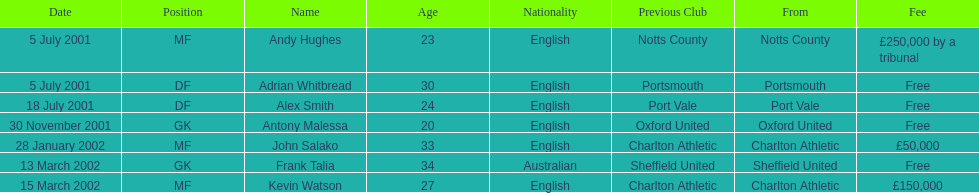What was the transfer fee to transfer kevin watson? £150,000. 